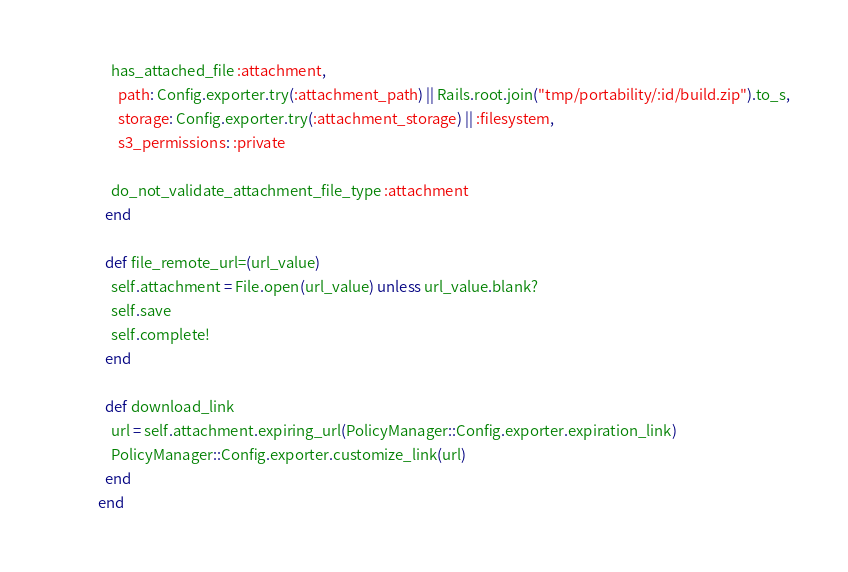<code> <loc_0><loc_0><loc_500><loc_500><_Ruby_>
    has_attached_file :attachment,
      path: Config.exporter.try(:attachment_path) || Rails.root.join("tmp/portability/:id/build.zip").to_s,
      storage: Config.exporter.try(:attachment_storage) || :filesystem,
      s3_permissions: :private

    do_not_validate_attachment_file_type :attachment
  end

  def file_remote_url=(url_value)
    self.attachment = File.open(url_value) unless url_value.blank?
    self.save
    self.complete!
  end

  def download_link
    url = self.attachment.expiring_url(PolicyManager::Config.exporter.expiration_link)
    PolicyManager::Config.exporter.customize_link(url)
  end
end</code> 